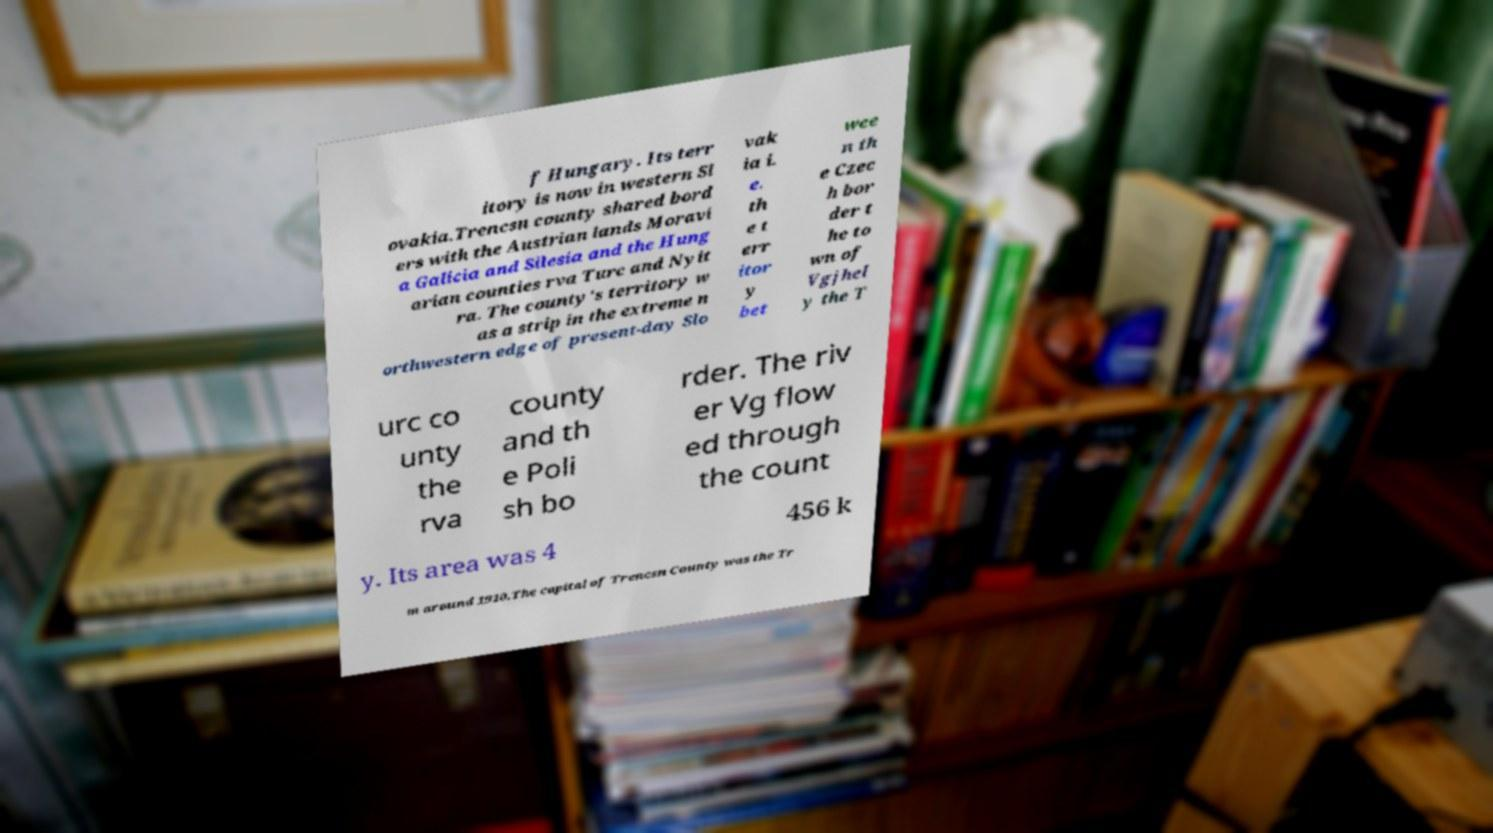Please identify and transcribe the text found in this image. f Hungary. Its terr itory is now in western Sl ovakia.Trencsn county shared bord ers with the Austrian lands Moravi a Galicia and Silesia and the Hung arian counties rva Turc and Nyit ra. The county's territory w as a strip in the extreme n orthwestern edge of present-day Slo vak ia i. e. th e t err itor y bet wee n th e Czec h bor der t he to wn of Vgjhel y the T urc co unty the rva county and th e Poli sh bo rder. The riv er Vg flow ed through the count y. Its area was 4 456 k m around 1910.The capital of Trencsn County was the Tr 